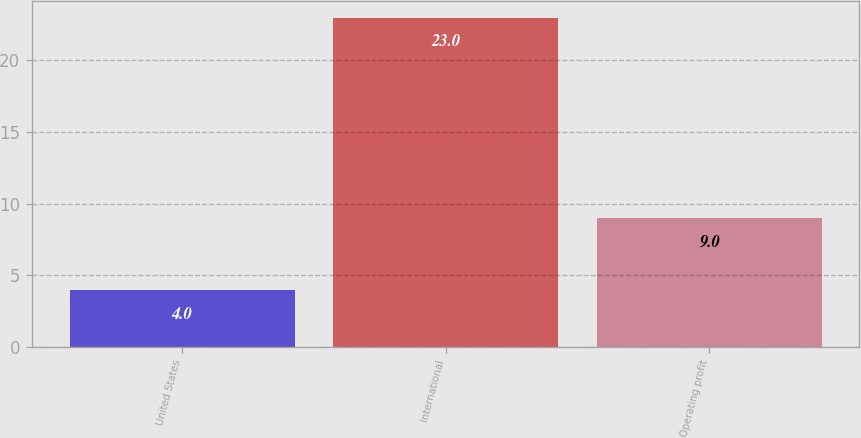Convert chart. <chart><loc_0><loc_0><loc_500><loc_500><bar_chart><fcel>United States<fcel>International<fcel>Operating profit<nl><fcel>4<fcel>23<fcel>9<nl></chart> 